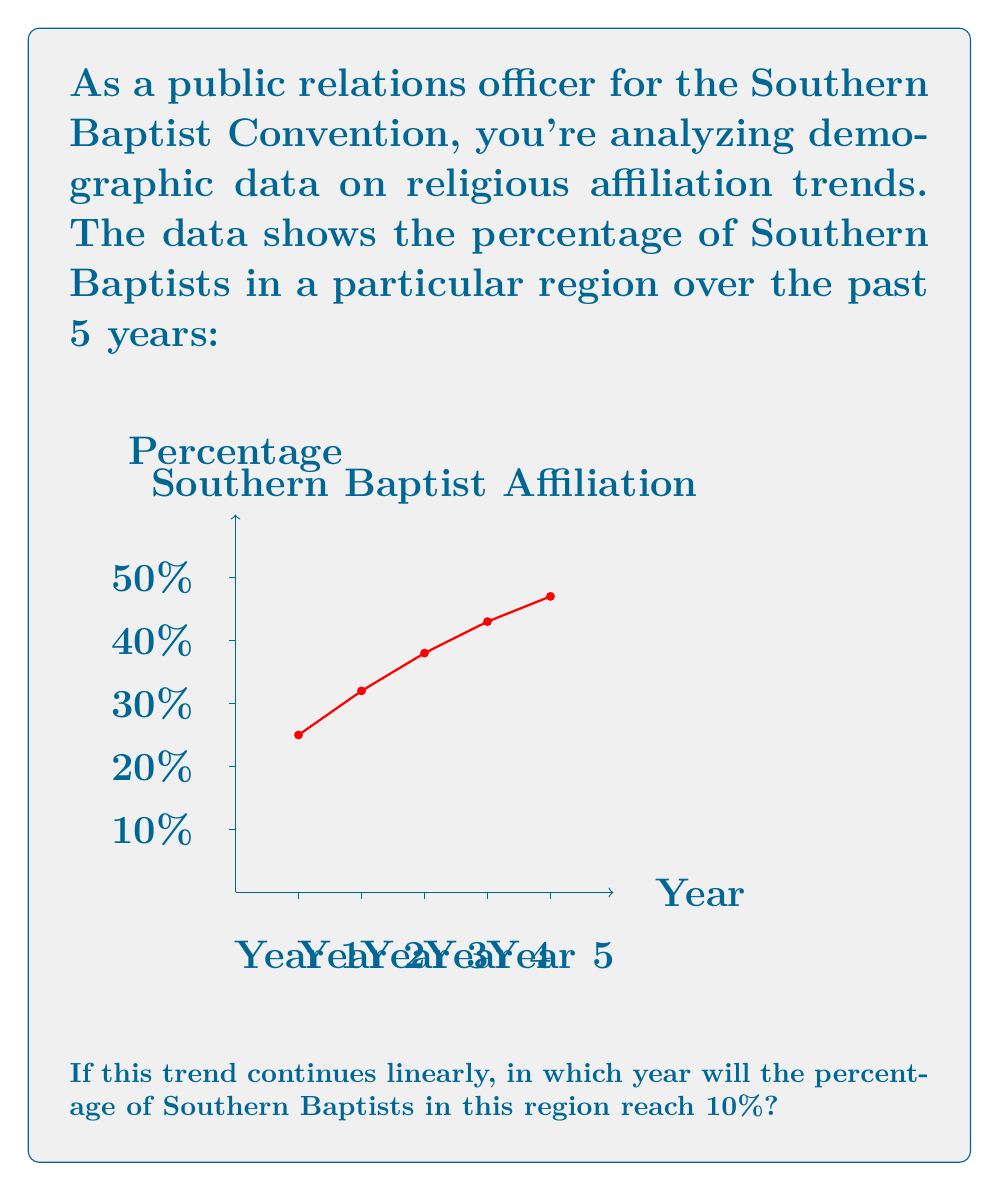Can you solve this math problem? To solve this problem, we need to follow these steps:

1. Determine the rate of change (slope) of the trend:
   Let's use the first and last data points to calculate the slope.
   $$\text{Slope} = \frac{y_2 - y_1}{x_2 - x_1} = \frac{4.7\% - 2.5\%}{5 - 1} = \frac{2.2\%}{4} = 0.55\% \text{ per year}$$

2. Find the equation of the line:
   Using the point-slope form: $y - y_1 = m(x - x_1)$
   Let's use the last data point (5, 4.7%)
   $y - 4.7 = 0.55(x - 5)$
   $y = 0.55x + 2.05$

3. Solve for x when y = 10%:
   $10 = 0.55x + 2.05$
   $7.95 = 0.55x$
   $x = 7.95 / 0.55 = 14.45$

4. Interpret the result:
   Since x represents the number of years since the start of our data, and 14.45 is between 14 and 15, this means it will happen in the 15th year.

5. Calculate the actual year:
   If Year 1 in our data is the current year, then Year 15 will be 14 years from now.
Answer: 14 years from now 